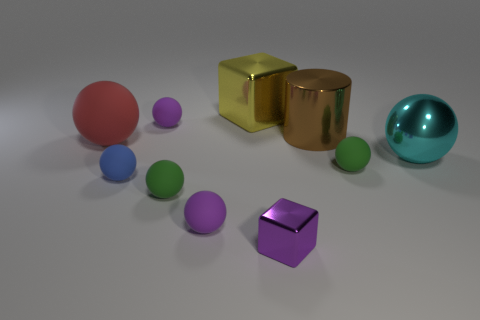Do the tiny metallic object and the metallic sphere have the same color?
Keep it short and to the point. No. What number of tiny purple blocks are in front of the cube in front of the small object on the right side of the tiny block?
Keep it short and to the point. 0. What is the shape of the big red thing that is made of the same material as the blue object?
Give a very brief answer. Sphere. There is a large object to the left of the metal cube behind the tiny ball that is behind the brown thing; what is it made of?
Your answer should be very brief. Rubber. How many objects are tiny matte things that are behind the red rubber thing or green blocks?
Your answer should be compact. 1. How many other objects are the same shape as the large red thing?
Your response must be concise. 6. Is the number of cubes on the right side of the large cyan thing greater than the number of brown cylinders?
Ensure brevity in your answer.  No. There is a blue matte thing that is the same shape as the big cyan metallic thing; what is its size?
Offer a very short reply. Small. Are there any other things that are the same material as the small cube?
Offer a very short reply. Yes. There is a large brown object; what shape is it?
Your answer should be very brief. Cylinder. 